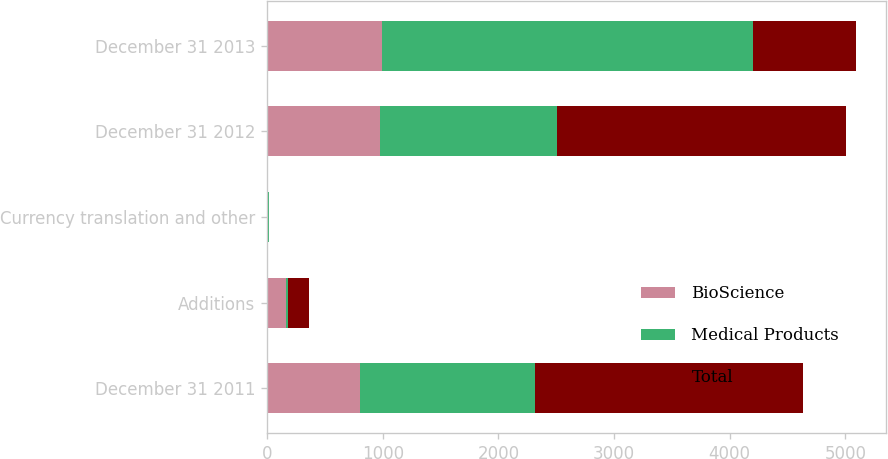Convert chart to OTSL. <chart><loc_0><loc_0><loc_500><loc_500><stacked_bar_chart><ecel><fcel>December 31 2011<fcel>Additions<fcel>Currency translation and other<fcel>December 31 2012<fcel>December 31 2013<nl><fcel>BioScience<fcel>806<fcel>161<fcel>8<fcel>975<fcel>991<nl><fcel>Medical Products<fcel>1511<fcel>21<fcel>5<fcel>1527<fcel>3214<nl><fcel>Total<fcel>2317<fcel>182<fcel>3<fcel>2502<fcel>890.5<nl></chart> 